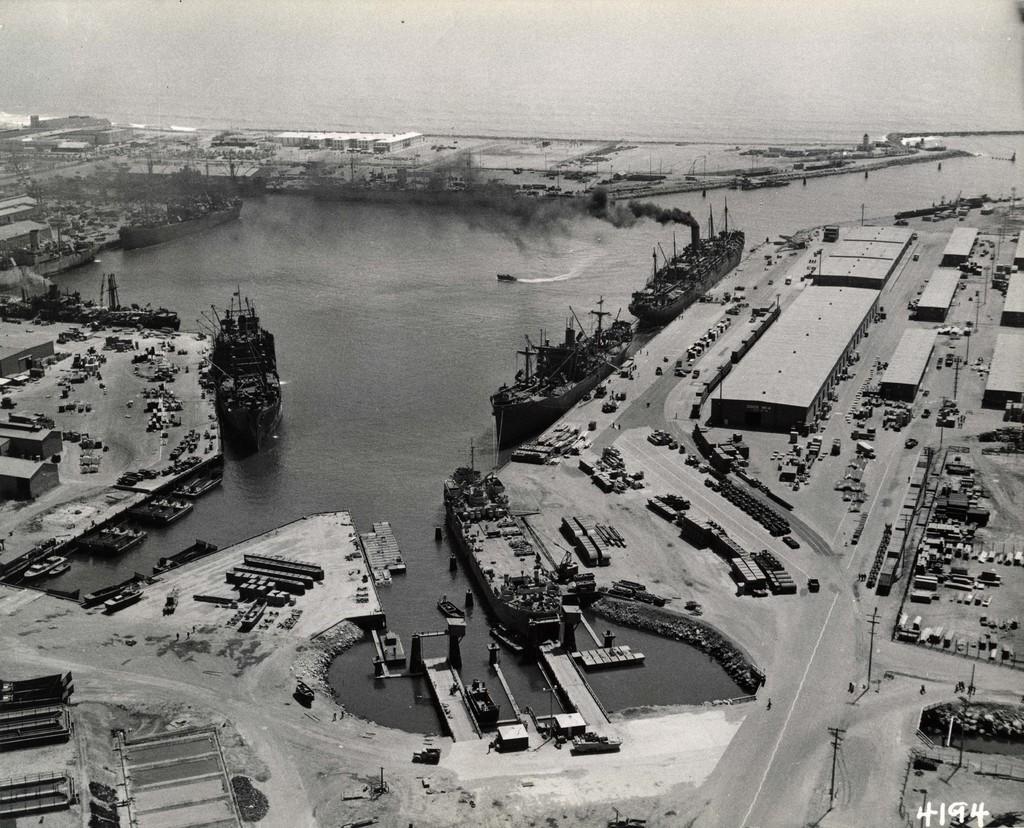Can you describe this image briefly? This is a black and white image and here we can see vehicles on the road, boats on the water and we can see buildings, sheds, poles and some other objects. 